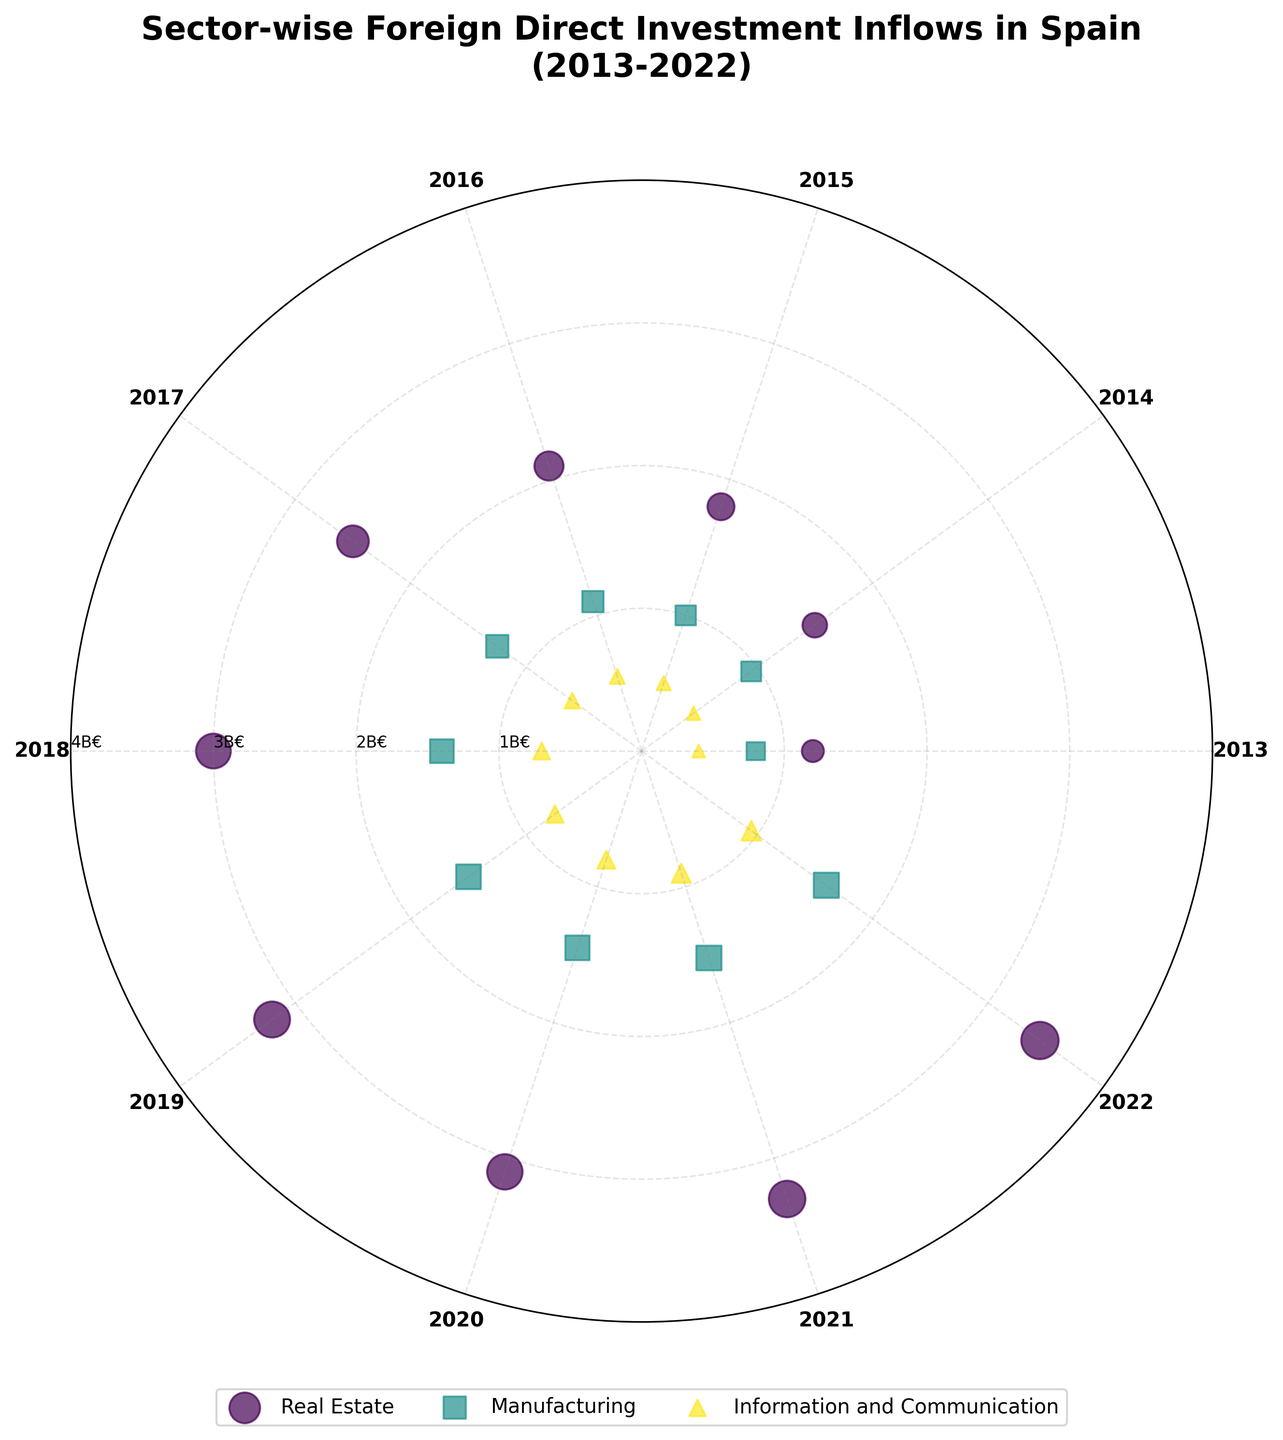What is the title of the figure? The title of the figure is usually placed at the top of the plot. Here, it reads "Sector-wise Foreign Direct Investment Inflows in Spain (2013-2022)."
Answer: Sector-wise Foreign Direct Investment Inflows in Spain (2013-2022) How many sectors are represented in the figure? By examining the legend or checking for different colors and markers, we can count the number of distinct sectors. The figure represents the following sectors: Real Estate, Manufacturing, and Information and Communication.
Answer: 3 Which sector received the highest investment in 2022? Looking at the points for 2022 around the polar plot, we can identify which sector's marker is farthest from the center. The Real Estate sector seems to have the highest investment in 2022.
Answer: Real Estate What range of years is covered in the figure? The years can be identified by the labels around the polar plot. The range of years covered is from 2013 to 2022.
Answer: 2013 to 2022 What is the maximum value of foreign direct investment shown in the figure, and in which sector and year did it occur? To find the maximum value, look for the data point farthest from the center in the polar plot. The maximum value is approximately 3450 million euros, which occurs in the Real Estate sector in 2022.
Answer: 3450 million euros, Real Estate, 2022 How does the investment trend in the Manufacturing sector change from 2013 to 2022? Following the points corresponding to the Manufacturing sector around the plot, we see an increasing trend in investment from 800 million euros in 2013 to 1600 million euros in 2022.
Answer: Increasing trend Which sector showed the least variation in investment over the years? By comparing the spread and positioning of the data points for each sector, the Information and Communication sector shows the least variation, as the points are relatively closer together than other sectors.
Answer: Information and Communication What is the investment difference in the Real Estate sector between 2013 and 2022? To find the difference, subtract the 2013 investment value from the 2022 value. For Real Estate, this is 3450 million euros (2022) - 1200 million euros (2013) = 2250 million euros.
Answer: 2250 million euros Which year had the overall highest foreign direct investment inflows across all sectors? By checking the distances of points from the center for all the sectors in each year, 2022 seems to have the highest overall investment since the points are the farthest from the center across all sectors.
Answer: 2022 Which two sectors received comparable investments in 2017? By observing the plot for the year 2017, the Manufacturing and Information and Communication sectors received relatively similar investments, with 1250 million euros and 600 million euros respectively.
Answer: Manufacturing and Information and Communication 